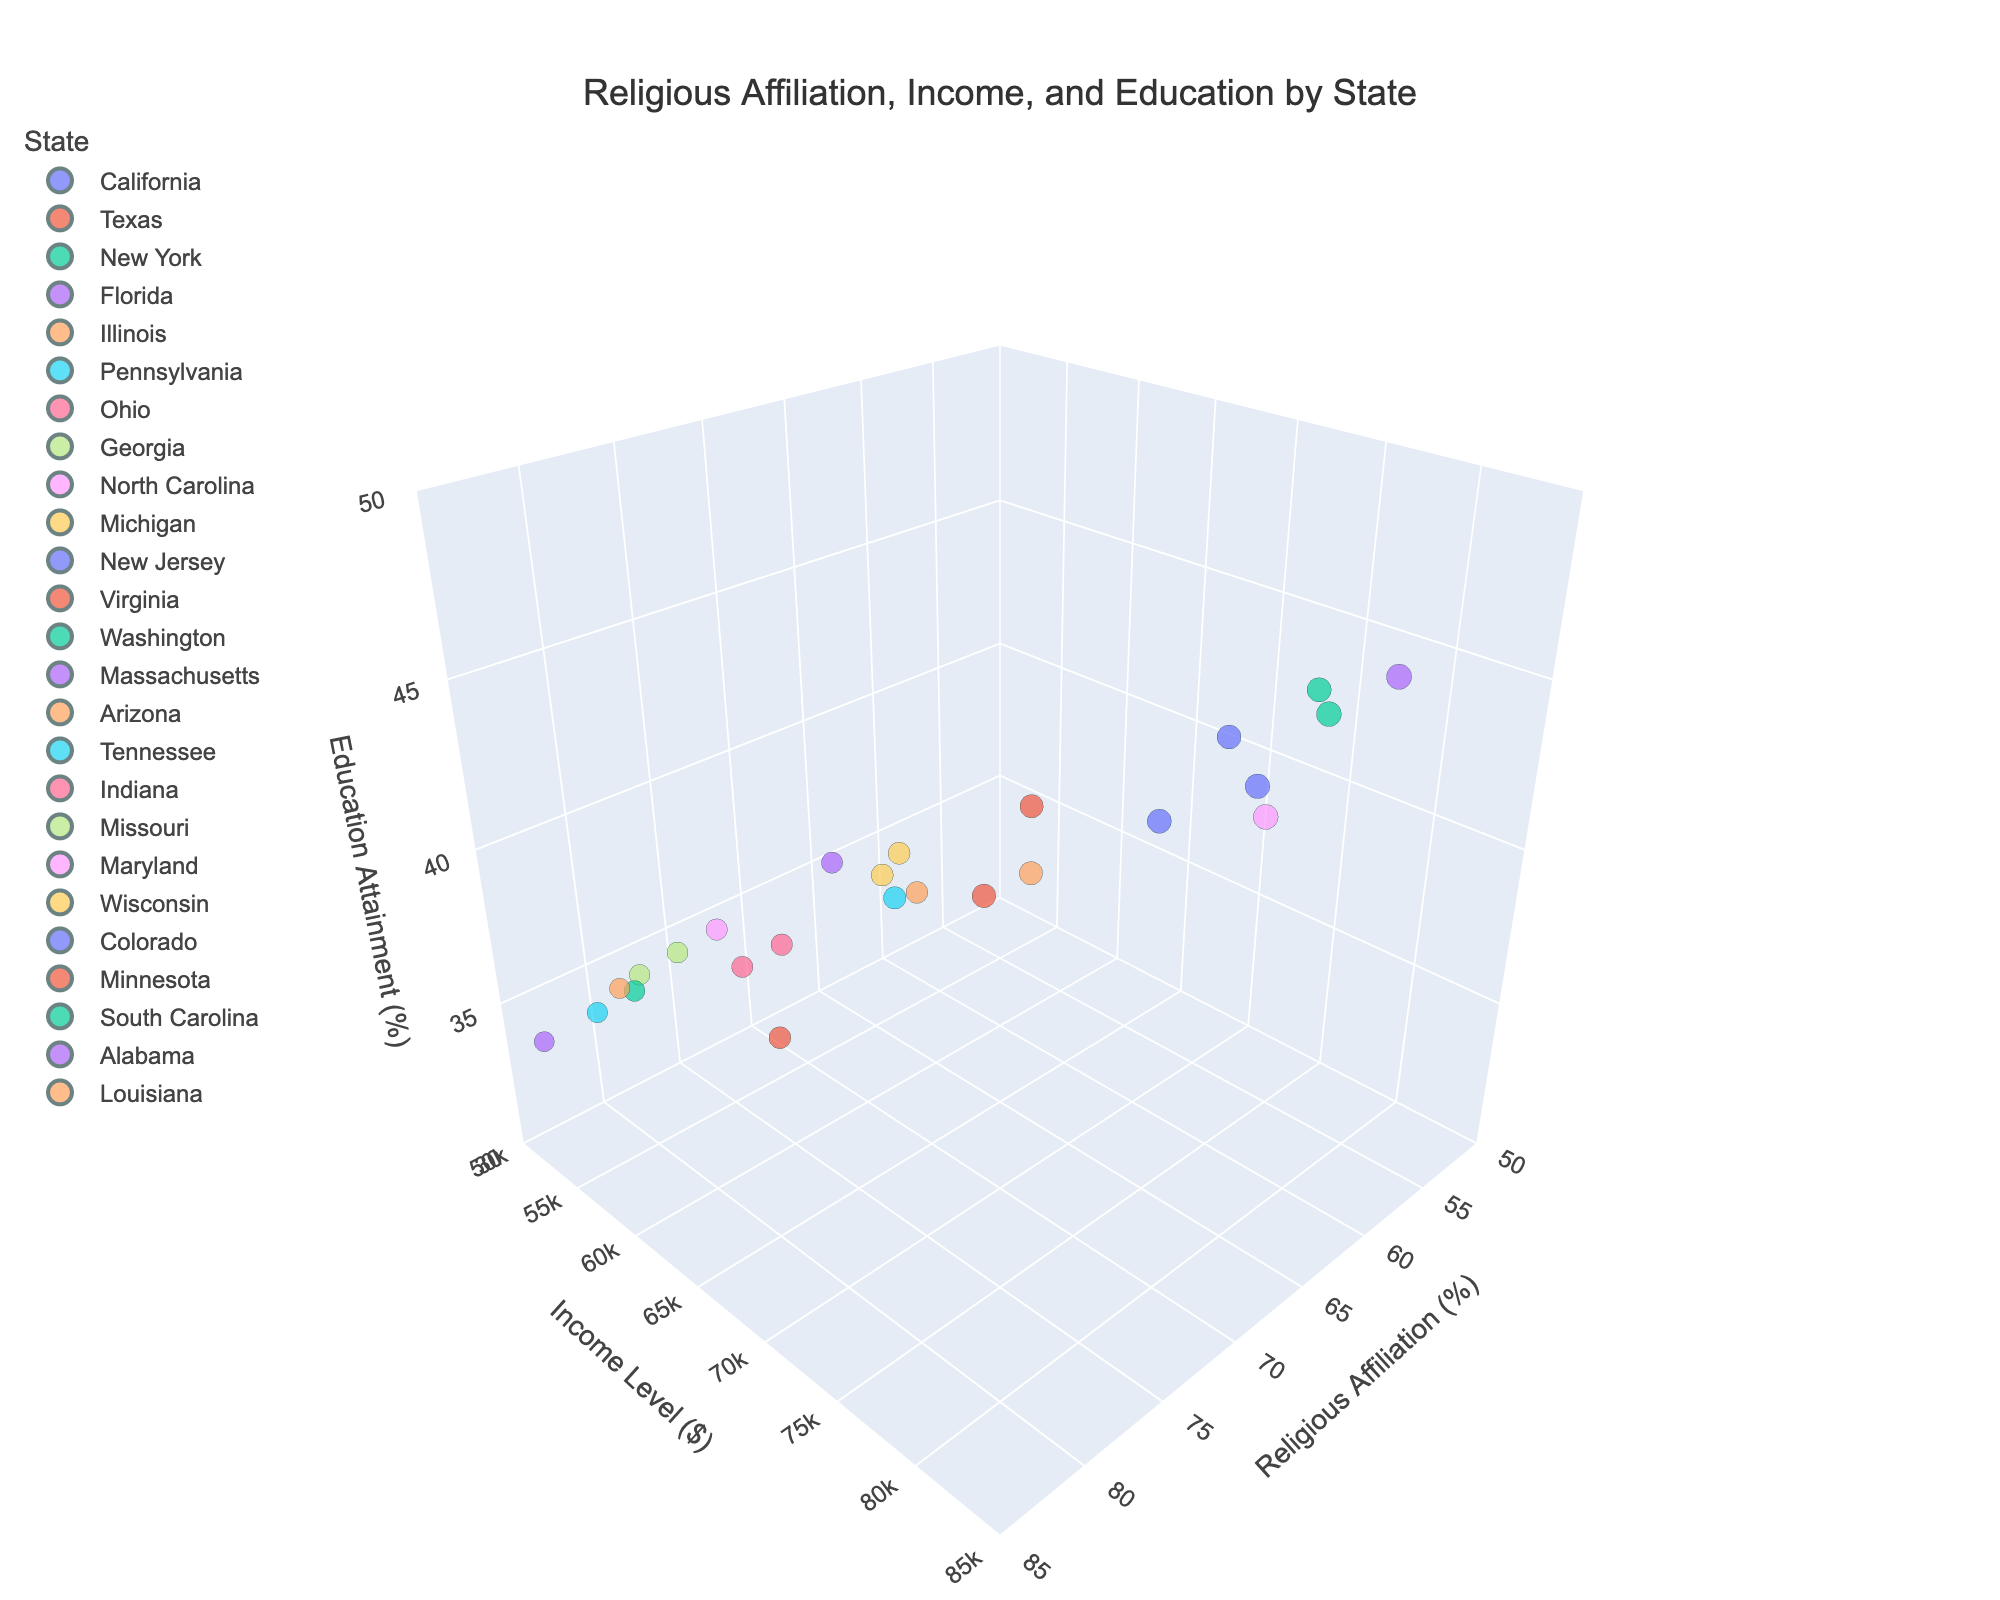What's the title of the 3D scatter plot? The title of the plot is displayed at the top and reads "Religious Affiliation, Income, and Education by State."
Answer: Religious Affiliation, Income, and Education by State What is the range of values for the x-axis representing Religious Affiliation (%)? The x-axis range is shown from 50 to 85, with tick marks every 5 units.
Answer: 50 to 85 Which state has the highest Religious Affiliation (%) and what is that value? By examining the data points, Alabama stands out with the highest value on the Religious Affiliation axis, which is 84%.
Answer: Alabama, 84% How many states have an Income Level ($) greater than $70,000? We identify and count the states where the data points surpass the $70,000 mark on the y-axis. These states are California, New York, New Jersey, Virginia, Washington, Massachusetts, and Maryland. Thus, there are seven states.
Answer: 7 Compare the Income Level and Education Attainment of California and Texas. Which state has higher values for both parameters? California has an Income Level of $75,000 and an Education Attainment of 42%, while Texas has an Income Level of $62,000 and an Education Attainment of 35%. Therefore, California has higher values for both parameters.
Answer: California What is the average Education Attainment (%) for states with a Religious Affiliation below 65%? The states below 65% Religious Affiliation are California, New York, New Jersey, Washington, Massachusetts, Maryland, and Colorado. Their Education Attainment percentages are 42, 45, 43, 44, 46, 43, and 43, respectively. Adding these values (42+45+43+44+46+43+43) yields 306. Dividing by the number of states (7), the average is 43.71%.
Answer: 43.71% Which state has the lowest Income Level ($) and what is that value? Observing the y-axis for the lowest data point, we see Alabama has the lowest Income Level, which is $52,000.
Answer: Alabama, $52,000 What's the combined Religious Affiliation (%) of the states with an Education Attainment of 35%? The states with an Education Attainment of 35% are Texas, Tennessee, Louisiana. Summing their Religious Affiliation values (77+82+80) results in 239.
Answer: 239 Are there any states where the Religious Affiliation (%) is below 60% and the Income Level ($) is above $75,000? By analyzing the data points, New York and Maryland have an Income Level above $75,000 (both $80,000) and a Religious Affiliation below 60% (60% and 64% respectively).
Answer: No Which state among the ones with Religious Affiliation (%) greater than 75% has the highest Education Attainment (%)? Sorting the states with Religious Affiliation greater than 75%, we see that North Carolina has the highest Education Attainment at 38%.
Answer: North Carolina 